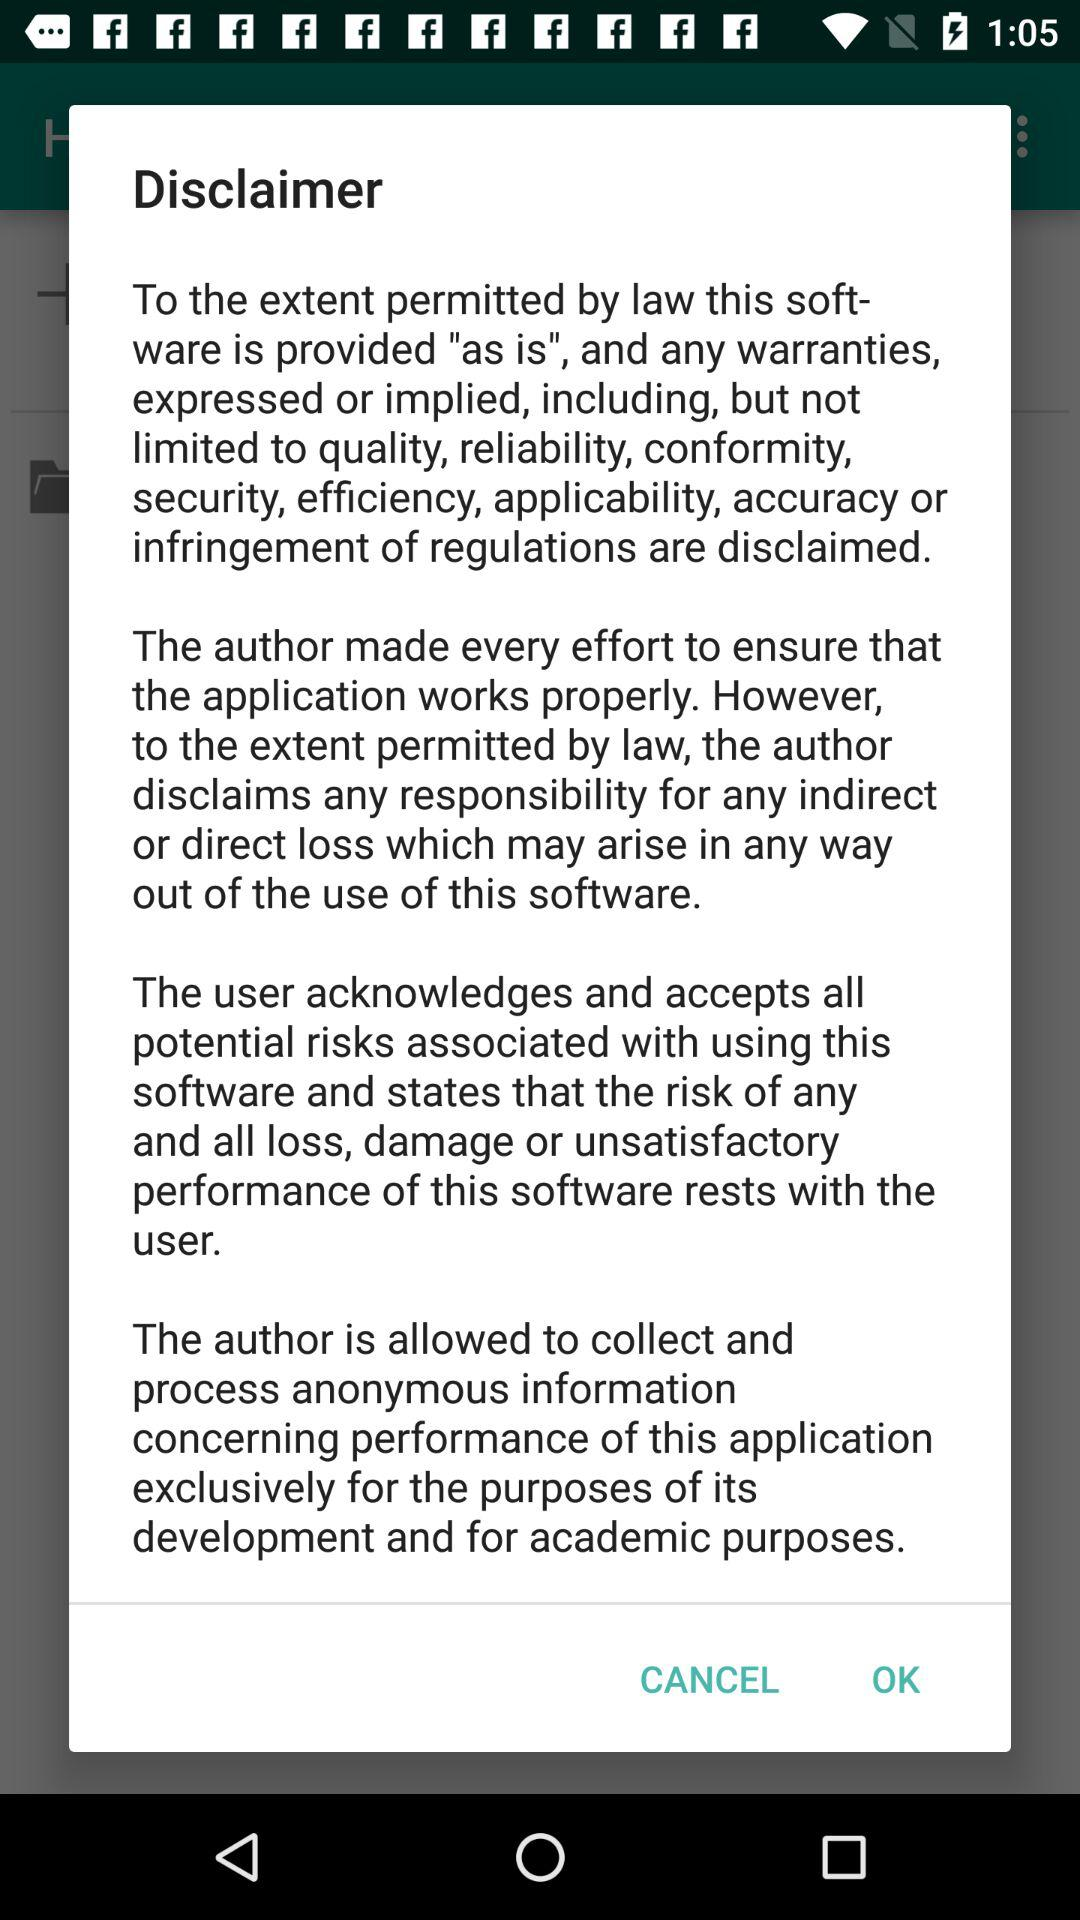How many disclaimers are there?
Answer the question using a single word or phrase. 4 